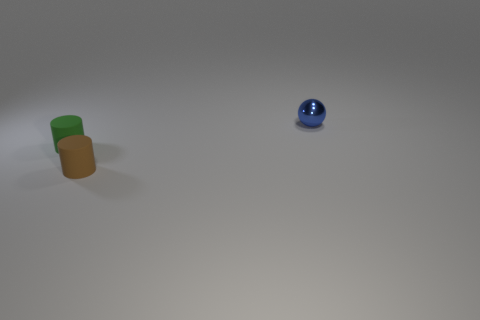There is a tiny object on the left side of the small brown matte thing; what color is it?
Offer a terse response. Green. Is the brown rubber object the same shape as the green thing?
Ensure brevity in your answer.  Yes. The thing that is both in front of the tiny blue metallic sphere and behind the small brown matte thing is what color?
Offer a terse response. Green. Is the size of the rubber thing left of the tiny brown thing the same as the blue thing that is behind the tiny green cylinder?
Your answer should be compact. Yes. What number of objects are objects that are in front of the tiny blue metal ball or tiny blue balls?
Provide a short and direct response. 3. What is the green thing made of?
Offer a terse response. Rubber. Does the blue sphere have the same size as the green matte cylinder?
Keep it short and to the point. Yes. How many cylinders are green things or green metal things?
Offer a terse response. 1. The small matte cylinder in front of the tiny thing to the left of the brown cylinder is what color?
Provide a short and direct response. Brown. Are there fewer small green rubber cylinders that are on the right side of the tiny blue ball than tiny cylinders that are behind the small green matte cylinder?
Offer a very short reply. No. 